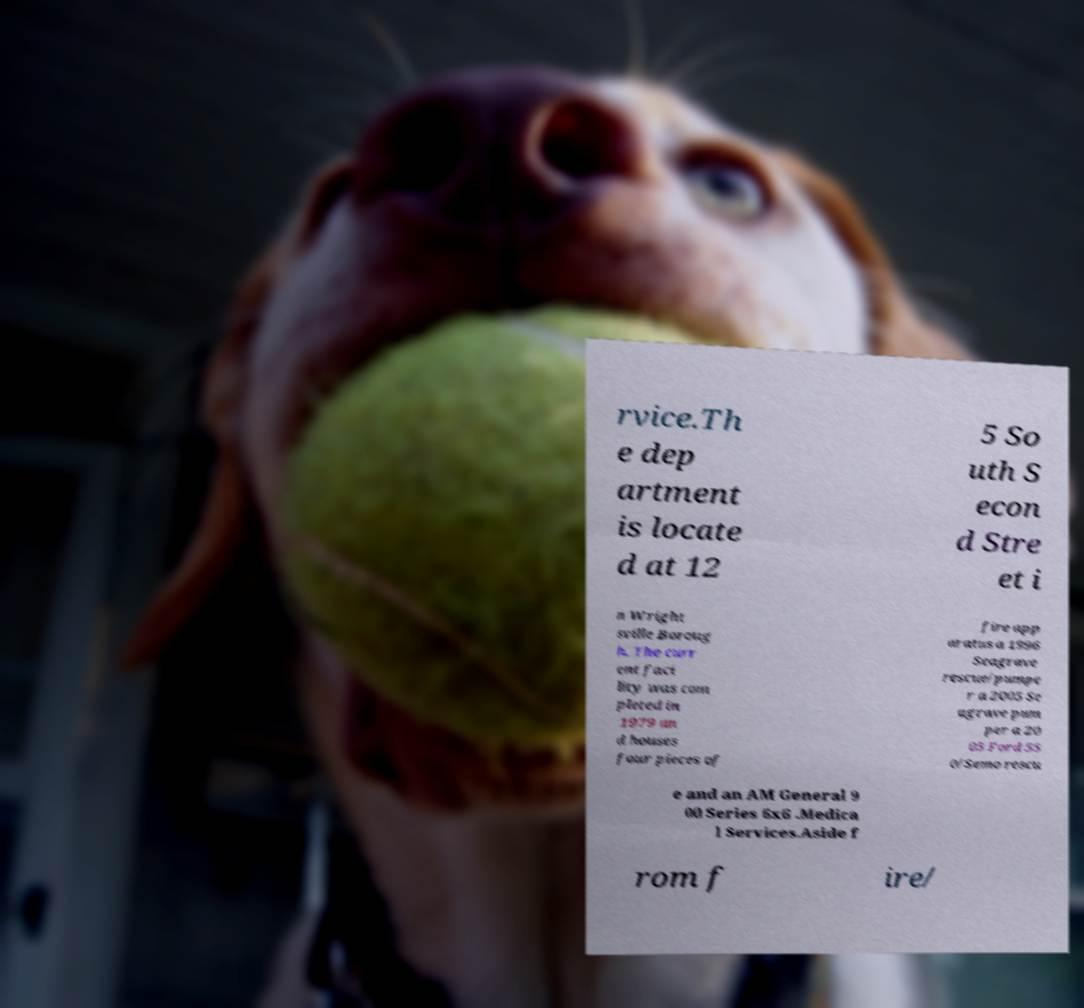Could you extract and type out the text from this image? rvice.Th e dep artment is locate d at 12 5 So uth S econ d Stre et i n Wright sville Boroug h. The curr ent faci lity was com pleted in 1979 an d houses four pieces of fire app aratus a 1996 Seagrave rescue/pumpe r a 2005 Se agrave pum per a 20 05 Ford 55 0/Semo rescu e and an AM General 9 00 Series 6x6 .Medica l Services.Aside f rom f ire/ 